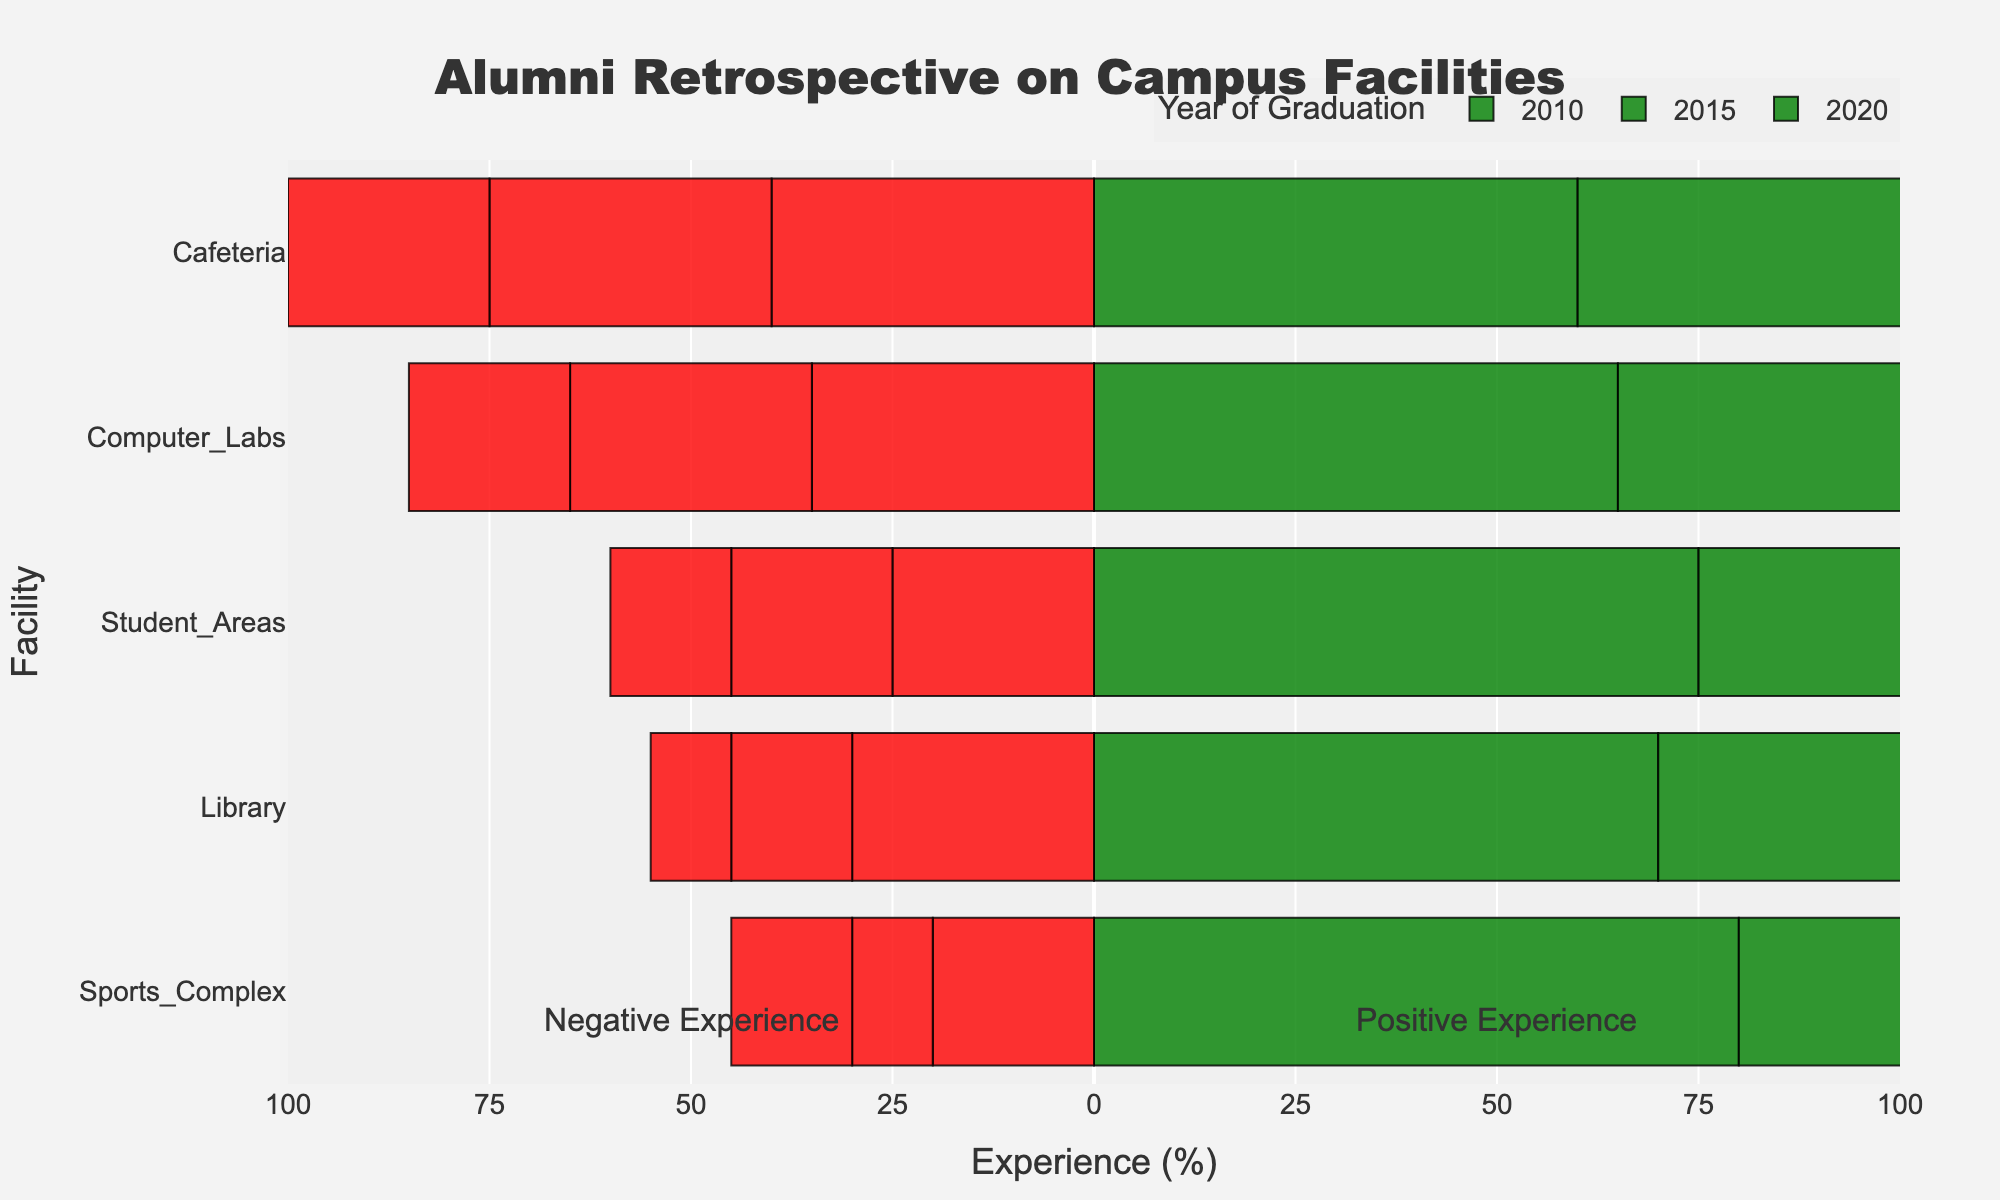how did the alumni experience of the library improve between 2010 and 2015? To find the improvement, we need to look at the percentage of positive experiences for the library in both 2010 and 2015. In 2010, the library had a 70% positive experience, and in 2015, it had an 85% positive experience. The improvement is 85% - 70% = 15%.
Answer: By 15% Which facility had the least improvement in positive experiences from 2010 to 2020? To find the least improvement, we compare the positive experiences of each facility in 2010 and 2020: Library (20%), Computer Labs (15%), Sports Complex (5%), Cafeteria (15%), and Student Areas (10%). The Sports Complex has the least improvement (5%).
Answer: Sports Complex What was the overall trend in positive experiences in the cafeteria from 2010 to 2020? To identify the trend, examine the percentage of positive experiences for the cafeteria across the years: 2010 - 60%, 2015 - 65%, 2020 - 75%. The positive experiences increased over time.
Answer: Increasing Compare the positive experiences for sports complexes in 2015 and computer labs in 2020. Which facility had a higher positive experience, and by how much? For sports complexes in 2015, the positive experience was 90%. For computer labs in 2020, it was 80%. The difference is 90% - 80% = 10%, and sports complexes in 2015 had higher positive experiences.
Answer: Sports Complex (by 10%) Identify the facility which showed the highest negative experience in 2020 and state the percentage. We need to locate the highest negative experience bar in 2020. For 2020, negative experiences were: Library (10%), Computer Labs (20%), Sports Complex (15%), Cafeteria (25%), Student Areas (15%). The Cafeteria showed the highest negative experience with 25%.
Answer: Cafeteria (25%) What is the average positive experience for student areas across all years shown? To calculate the average positive experience for student areas, add the percentages for all years and divide by the number of years: (75 + 80 + 85) / 3 = 80%.
Answer: 80% In which year did the alumni report the highest positive experience for computer labs, and what was the percentage? We need to compare the positive experiences for computer labs across the years: 2010 - 65%, 2015 - 70%, 2020 - 80%. The highest positive experience occurred in 2020, with 80%.
Answer: 2020 (80%) Which year and facility combination had the closest balance between positive and negative experiences? To find the closest balance, look for a facility where the percentage difference between positive and negative experiences is the smallest. In 2010, Computer Labs had a 65% positive and 35% negative experience, showing a difference of 30%.
Answer: 2010, Computer Labs Was there any facility that consistently had less than 20% negative experience through all the years? Check if any facility had a negative experience below 20% in each year: Library (30%, 15%, 10%), Computer Labs (35%, 30%, 20%), Sports Complex (20%, 10%, 15%), Cafeteria (40%, 35%, 25%), Student Areas (25%, 20%, 15%). No facility met this criteria.
Answer: No 